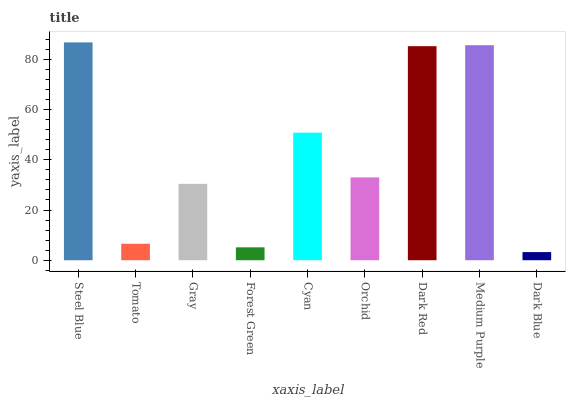Is Dark Blue the minimum?
Answer yes or no. Yes. Is Steel Blue the maximum?
Answer yes or no. Yes. Is Tomato the minimum?
Answer yes or no. No. Is Tomato the maximum?
Answer yes or no. No. Is Steel Blue greater than Tomato?
Answer yes or no. Yes. Is Tomato less than Steel Blue?
Answer yes or no. Yes. Is Tomato greater than Steel Blue?
Answer yes or no. No. Is Steel Blue less than Tomato?
Answer yes or no. No. Is Orchid the high median?
Answer yes or no. Yes. Is Orchid the low median?
Answer yes or no. Yes. Is Dark Blue the high median?
Answer yes or no. No. Is Steel Blue the low median?
Answer yes or no. No. 